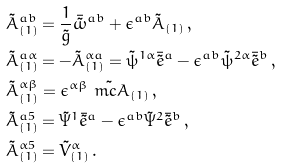<formula> <loc_0><loc_0><loc_500><loc_500>& \tilde { A } ^ { a b } _ { ( 1 ) } = \frac { 1 } { \tilde { g } } \bar { \tilde { \omega } } ^ { a b } + \epsilon ^ { a b } \tilde { A } _ { ( 1 ) } \, , \\ & \tilde { A } ^ { a \alpha } _ { ( 1 ) } = - \tilde { A } ^ { \alpha a } _ { ( 1 ) } = \tilde { \psi } ^ { 1 \alpha } \bar { \tilde { e } } ^ { a } - \epsilon ^ { a b } \tilde { \psi } ^ { 2 \alpha } \bar { \tilde { e } } ^ { b } \, , \\ & \tilde { A } ^ { \alpha \beta } _ { ( 1 ) } = \epsilon ^ { \alpha \beta } \tilde { \ m c { A } } _ { ( 1 ) } \, , \\ & \tilde { A } ^ { a 5 } _ { ( 1 ) } = \tilde { \Psi } ^ { 1 } \bar { \tilde { e } } ^ { a } - \epsilon ^ { a b } \tilde { \Psi } ^ { 2 } \bar { \tilde { e } } ^ { b } \, , \\ & \tilde { A } ^ { \alpha 5 } _ { ( 1 ) } = \tilde { V } ^ { \alpha } _ { ( 1 ) } \, .</formula> 